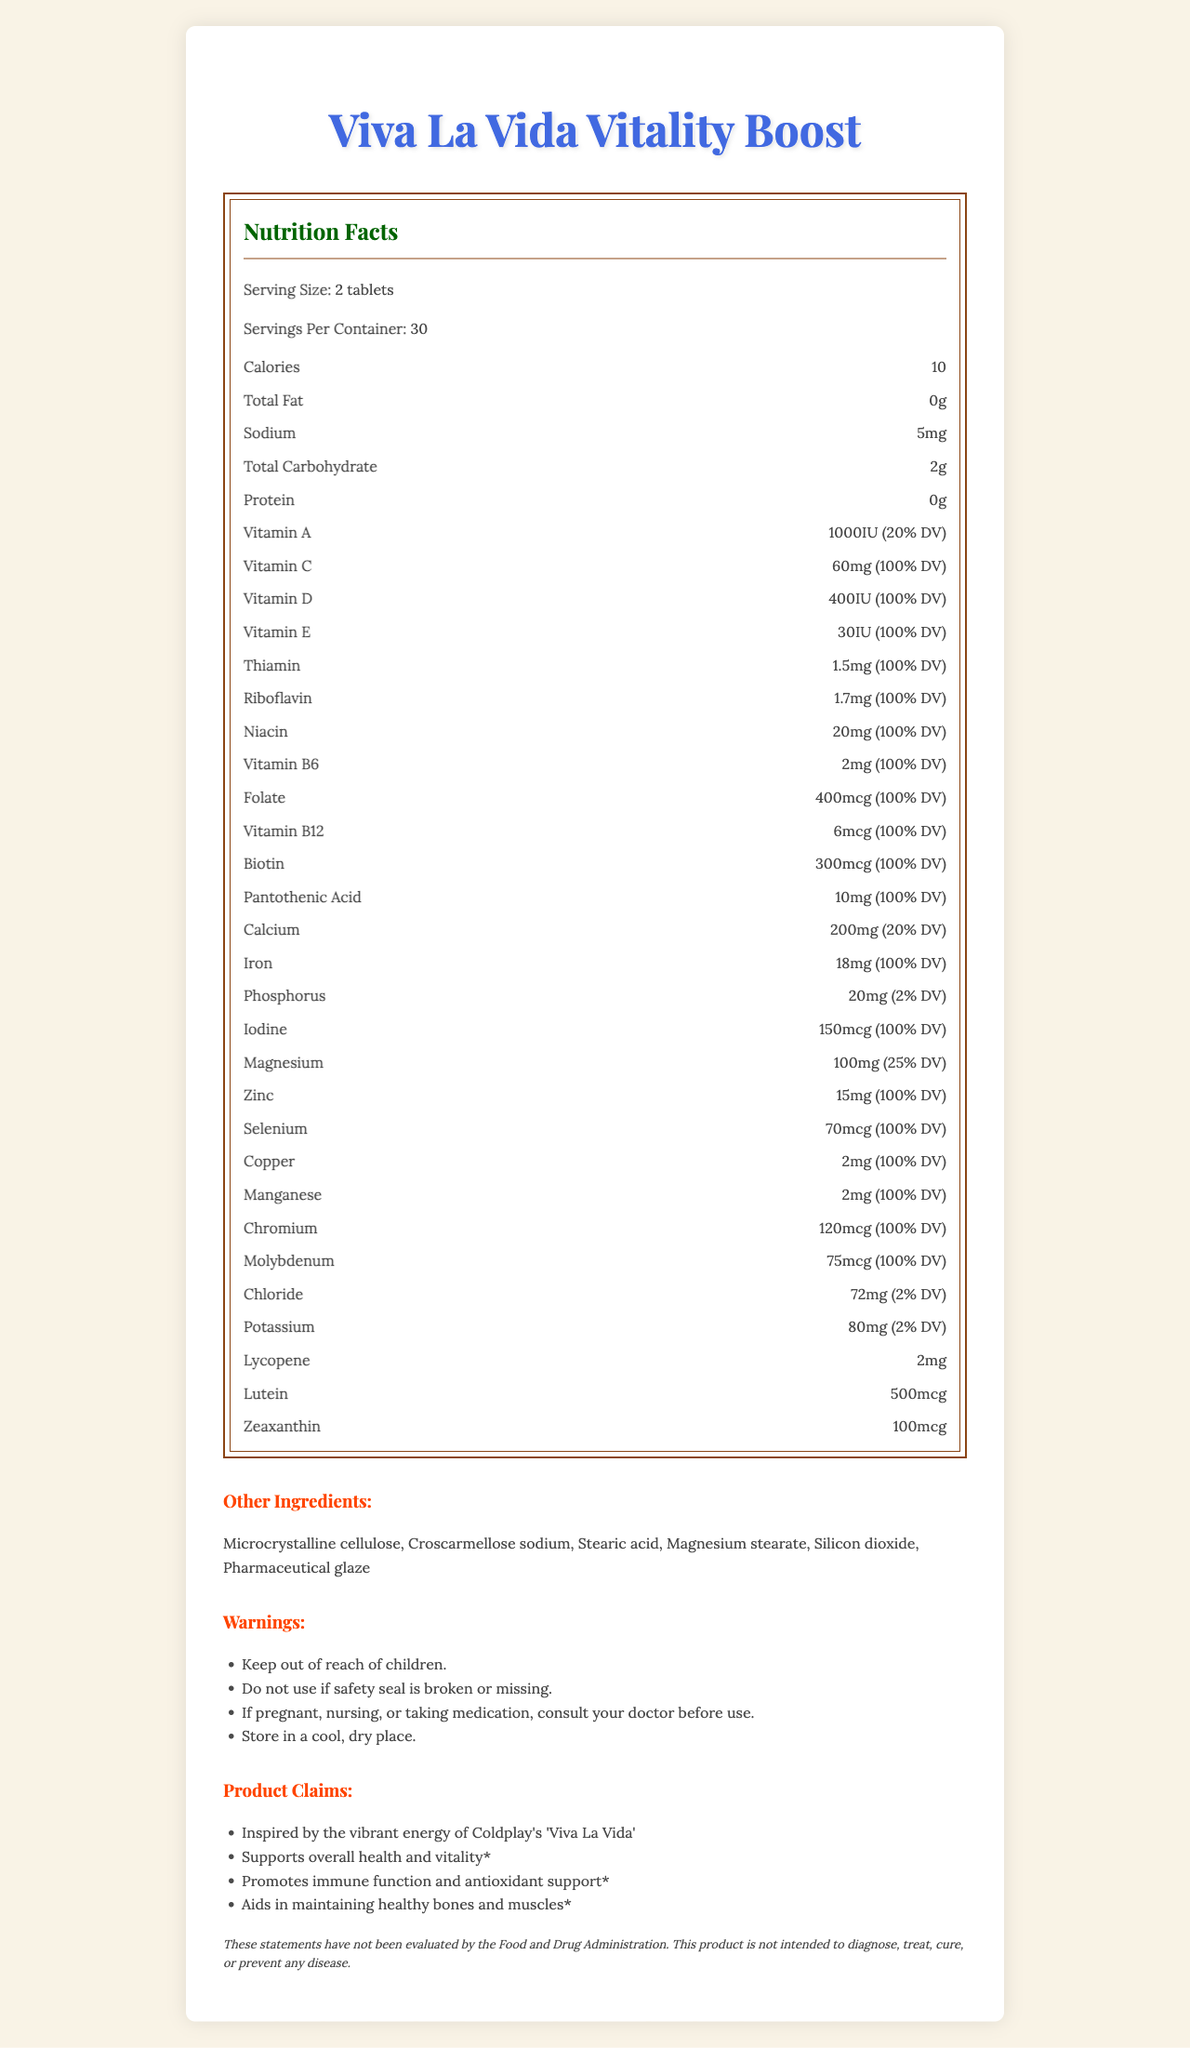what is the serving size? The serving size is given directly near the top of the Nutrition Facts section.
Answer: 2 tablets how many servings are in the container? The number of servings per container is listed just below the serving size.
Answer: 30 how many calories are in one serving? The number of calories per serving is given in the Nutrition Facts section under calories.
Answer: 10 what is the percentage Daily Value of Vitamin C? The DV percentage for Vitamin C is listed as 100% next to the amount of Vitamin C.
Answer: 100% DV what ingredients are used in the product, other than the main active nutrients? The list of other ingredients is presented under the "Other Ingredients" section in the document.
Answer: Microcrystalline cellulose, Croscarmellose sodium, Stearic acid, Magnesium stearate, Silicon dioxide, Pharmaceutical glaze which vitamin is present in the highest quantity? A. Vitamin A B. Vitamin C C. Vitamin D D. Vitamin E Vitamin C is present at 60mg which corresponds to 100% DV, the same percentage DV as Vitamin D and E but more is listed in mg quantity.
Answer: B which of the following elicits immune function support from the product claims? 1. Inspired by the vibrant energy of Coldplay's 'Viva La Vida' 2. Supports overall health and vitality 3. Promotes immune function and antioxidant support 4. Aids in maintaining healthy bones and muscles The claim "Promotes immune function and antioxidant support" directly mentions immune function support.
Answer: 3 is the product free from allergies for common allergens like milk, egg, and fish? The allergen information confirms that the product contains no milk, egg, fish, crustacean shellfish, tree nuts, wheat, peanuts, or soybeans.
Answer: Yes are there any specific warnings mentioned for using this product? The warnings section lists several specific warnings, such as keeping out of reach of children, not using if the seal is broken, and consulting a doctor if pregnant or nursing.
Answer: Yes how would you describe the overall document? The document provides comprehensive information about the Viva La Vida Vitality Boost supplement in a visually engaging format, including all necessary nutritional data and usage instructions, enhanced by decorative elements inspired by the "Viva La Vida" theme.
Answer: It is a nutrition facts label for a vitamin supplement called "Viva La Vida Vitality Boost" styled with an ornate, baroque-inspired design. It details the nutritional information, ingredients, usage instructions, warnings, allergy information, and marketing claims, presented in a visually appealing manner with decorative border elements and a consistent color palette. what is the manufacturing facility certification? The allergen information states that the product is produced in a GMP-certified facility.
Answer: GMP-certified how much potassium does one serving contain? The potassium content per serving is listed under the Nutrition Facts section.
Answer: 80mg does the product contain lutein, and if so, in what quantity? Lutein is listed with a quantity of 500mcg in the Nutrition Facts section.
Answer: Yes, 500mcg does the product contain sugars? Total sugars are not listed in the nutritional elements, indicating it contains no sugars.
Answer: No is the marketing claim "Supports heart health and vitality" true for this product? The document does not list this specific claim under the marketing claims section.
Answer: Not enough information which typography style is used for the product name? The product name in the document uses the Edwardian Script ITC font.
Answer: Edwardian Script ITC is the dietary supplement intended to diagnose, treat, cure, or prevent any disease? The footnote clearly states that the product is not intended to diagnose, treat, cure, or prevent any disease.
Answer: No 